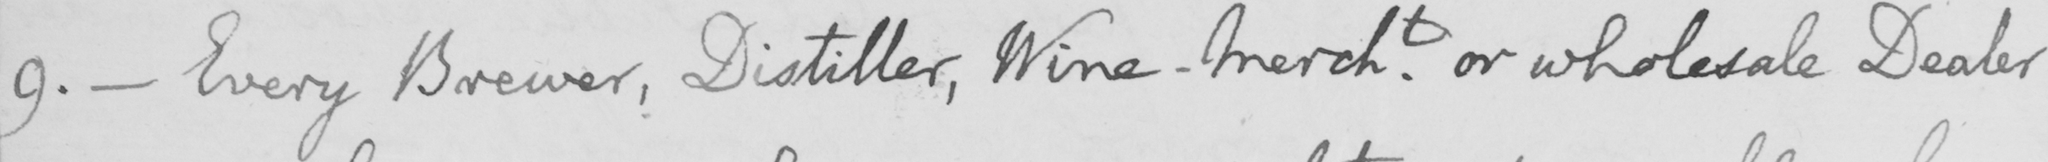Can you tell me what this handwritten text says? 9 .  _  Every Brewer , Distiller , Wine-Mercht or wholesale Dealer 